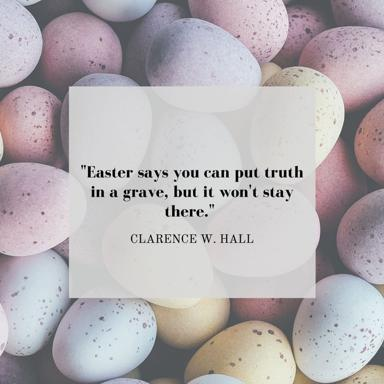How do the colors of the Easter eggs enhance the message of the quote? The pastel colors of the Easter eggs in the image provide a soft, hopeful backdrop which contrasts with the grave theme of the quote. These colors traditionally symbolize spring and renewal, complementing the quote's message about the resurgence and persistence of truth. The gentle hues suggest a peaceful emergence from adversity, underscoring the theme of revival and hope inherent in both Easter and Hall's words. 